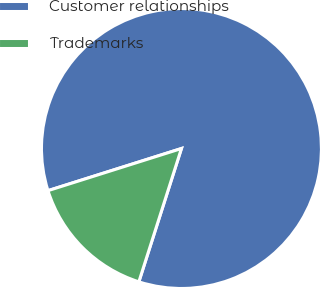Convert chart to OTSL. <chart><loc_0><loc_0><loc_500><loc_500><pie_chart><fcel>Customer relationships<fcel>Trademarks<nl><fcel>84.79%<fcel>15.21%<nl></chart> 